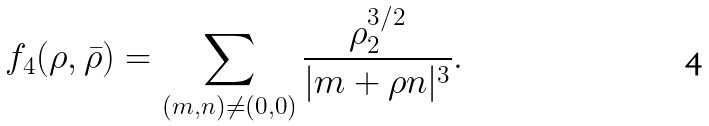Convert formula to latex. <formula><loc_0><loc_0><loc_500><loc_500>f _ { 4 } ( \rho , \bar { \rho } ) = \sum _ { ( m , n ) \ne ( 0 , 0 ) } \frac { \rho _ { 2 } ^ { 3 / 2 } } { | m + \rho n | ^ { 3 } } .</formula> 